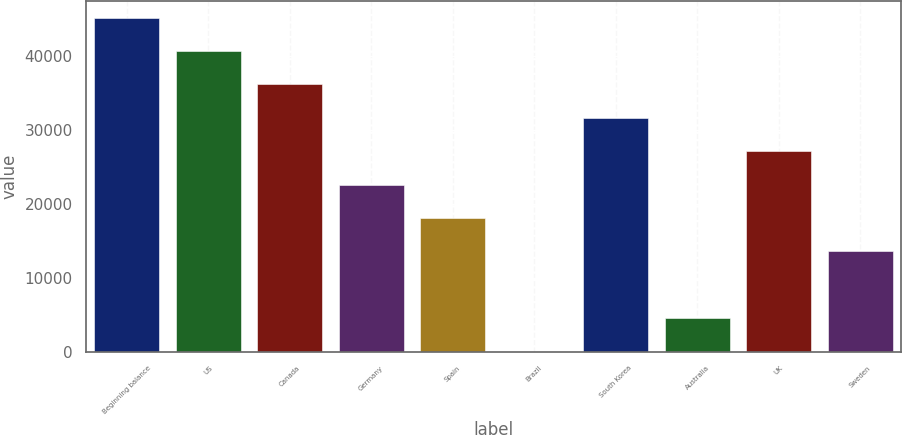Convert chart. <chart><loc_0><loc_0><loc_500><loc_500><bar_chart><fcel>Beginning balance<fcel>US<fcel>Canada<fcel>Germany<fcel>Spain<fcel>Brazil<fcel>South Korea<fcel>Australia<fcel>UK<fcel>Sweden<nl><fcel>45281<fcel>40753<fcel>36225<fcel>22641<fcel>18113<fcel>1<fcel>31697<fcel>4529<fcel>27169<fcel>13585<nl></chart> 